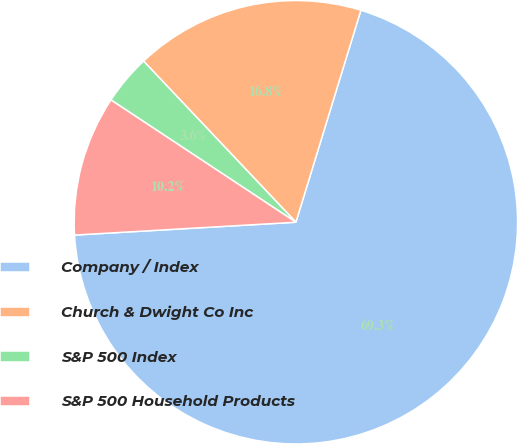Convert chart to OTSL. <chart><loc_0><loc_0><loc_500><loc_500><pie_chart><fcel>Company / Index<fcel>Church & Dwight Co Inc<fcel>S&P 500 Index<fcel>S&P 500 Household Products<nl><fcel>69.35%<fcel>16.79%<fcel>3.65%<fcel>10.22%<nl></chart> 